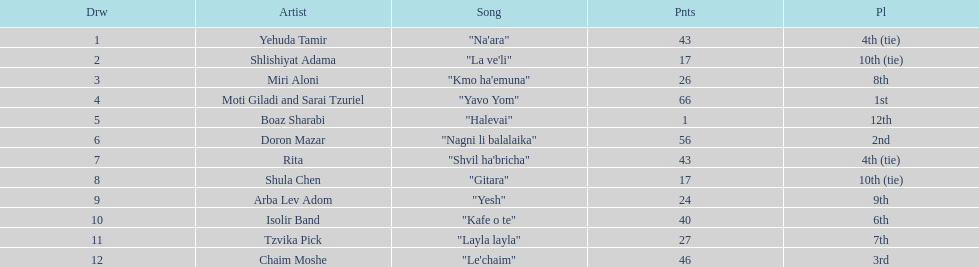What is the total amount of ties in this competition? 2. 